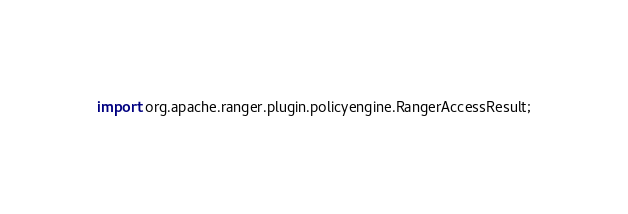<code> <loc_0><loc_0><loc_500><loc_500><_Java_>import org.apache.ranger.plugin.policyengine.RangerAccessResult;</code> 